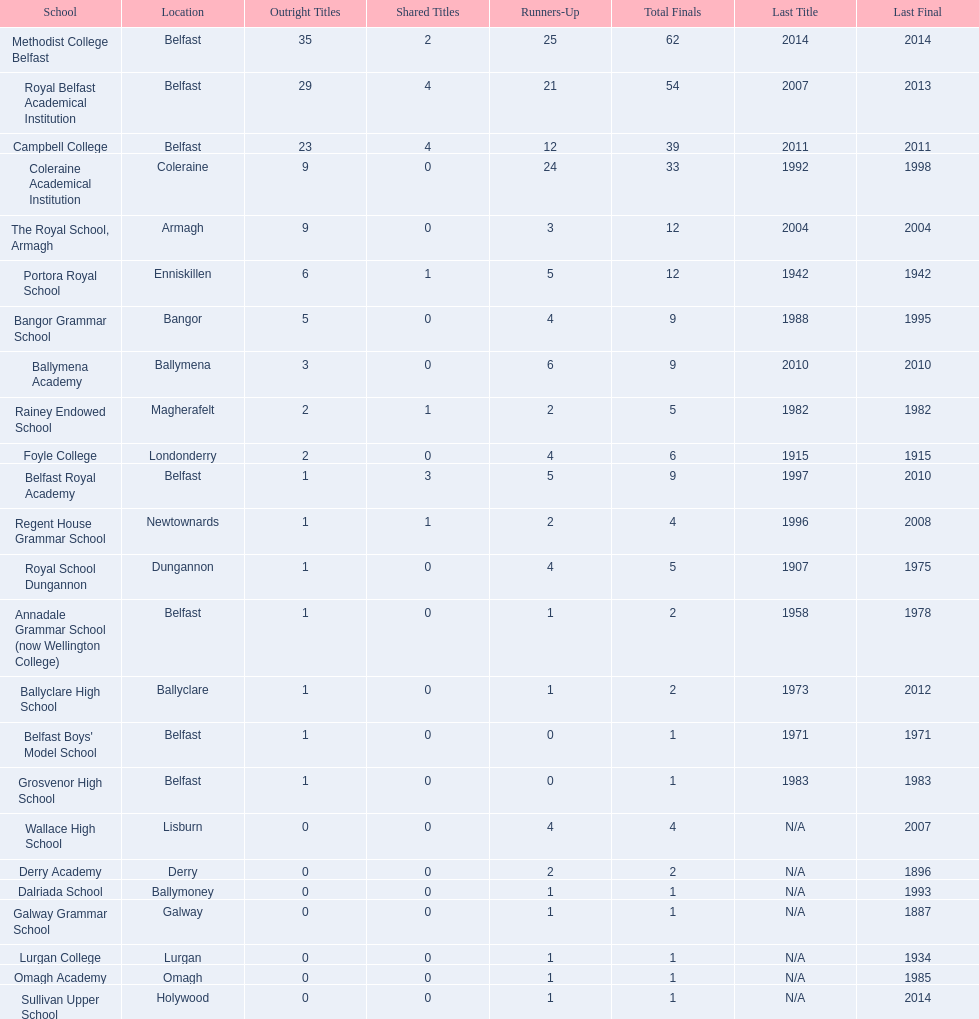What were the names of all the schools? Methodist College Belfast, Royal Belfast Academical Institution, Campbell College, Coleraine Academical Institution, The Royal School, Armagh, Portora Royal School, Bangor Grammar School, Ballymena Academy, Rainey Endowed School, Foyle College, Belfast Royal Academy, Regent House Grammar School, Royal School Dungannon, Annadale Grammar School (now Wellington College), Ballyclare High School, Belfast Boys' Model School, Grosvenor High School, Wallace High School, Derry Academy, Dalriada School, Galway Grammar School, Lurgan College, Omagh Academy, Sullivan Upper School. How many outright titles did they obtain? 35, 29, 23, 9, 9, 6, 5, 3, 2, 2, 1, 1, 1, 1, 1, 1, 1, 0, 0, 0, 0, 0, 0, 0. How many did coleraine academical institution get? 9. Which other school had an equal number of outright titles? The Royal School, Armagh. 